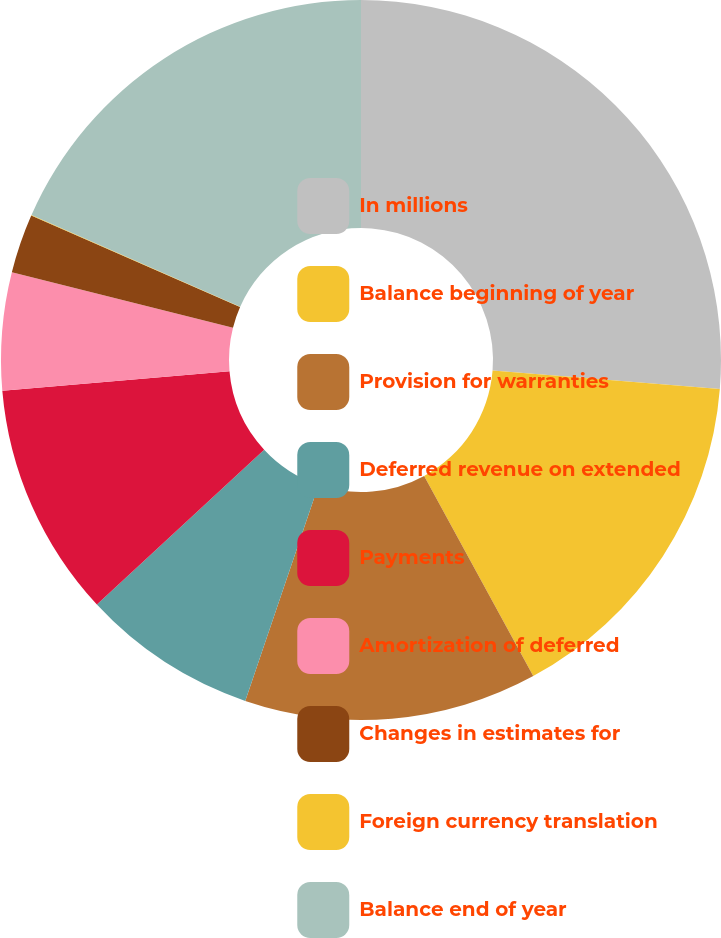Convert chart to OTSL. <chart><loc_0><loc_0><loc_500><loc_500><pie_chart><fcel>In millions<fcel>Balance beginning of year<fcel>Provision for warranties<fcel>Deferred revenue on extended<fcel>Payments<fcel>Amortization of deferred<fcel>Changes in estimates for<fcel>Foreign currency translation<fcel>Balance end of year<nl><fcel>26.28%<fcel>15.78%<fcel>13.15%<fcel>7.9%<fcel>10.53%<fcel>5.28%<fcel>2.65%<fcel>0.03%<fcel>18.4%<nl></chart> 